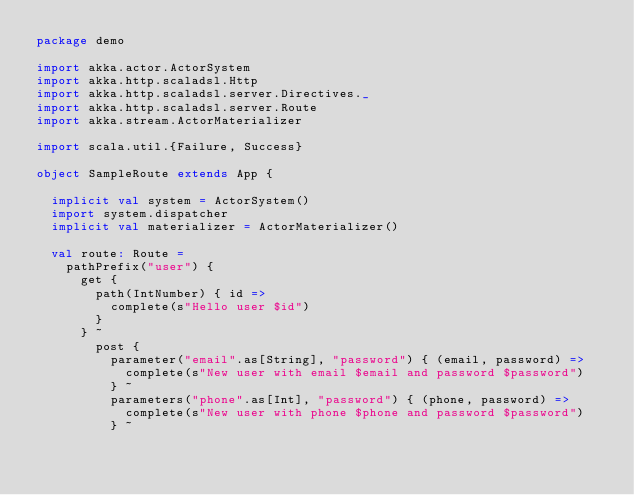Convert code to text. <code><loc_0><loc_0><loc_500><loc_500><_Scala_>package demo

import akka.actor.ActorSystem
import akka.http.scaladsl.Http
import akka.http.scaladsl.server.Directives._
import akka.http.scaladsl.server.Route
import akka.stream.ActorMaterializer

import scala.util.{Failure, Success}

object SampleRoute extends App {

  implicit val system = ActorSystem()
  import system.dispatcher
  implicit val materializer = ActorMaterializer()

  val route: Route =
    pathPrefix("user") {
      get {
        path(IntNumber) { id =>
          complete(s"Hello user $id")
        }
      } ~
        post {
          parameter("email".as[String], "password") { (email, password) =>
            complete(s"New user with email $email and password $password")
          } ~
          parameters("phone".as[Int], "password") { (phone, password) =>
            complete(s"New user with phone $phone and password $password")
          } ~</code> 